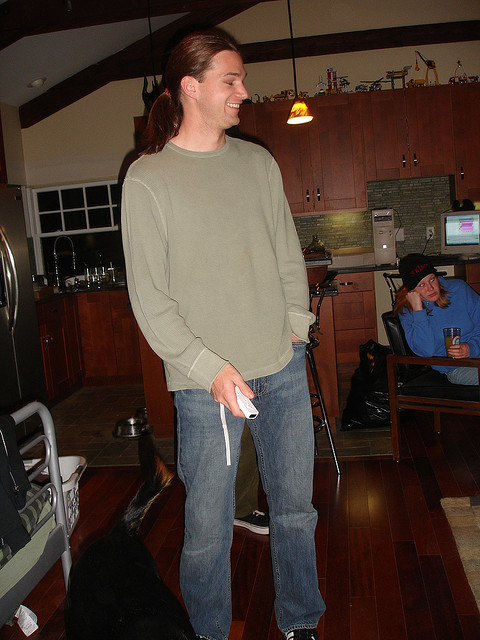<image>What character is the man dressed as? The man is not dressed as any character. However, some suggest he could be dressed as 'Mario' or a 'Monk'. What character is the man dressed as? I am not sure what character the man is dressed as. 